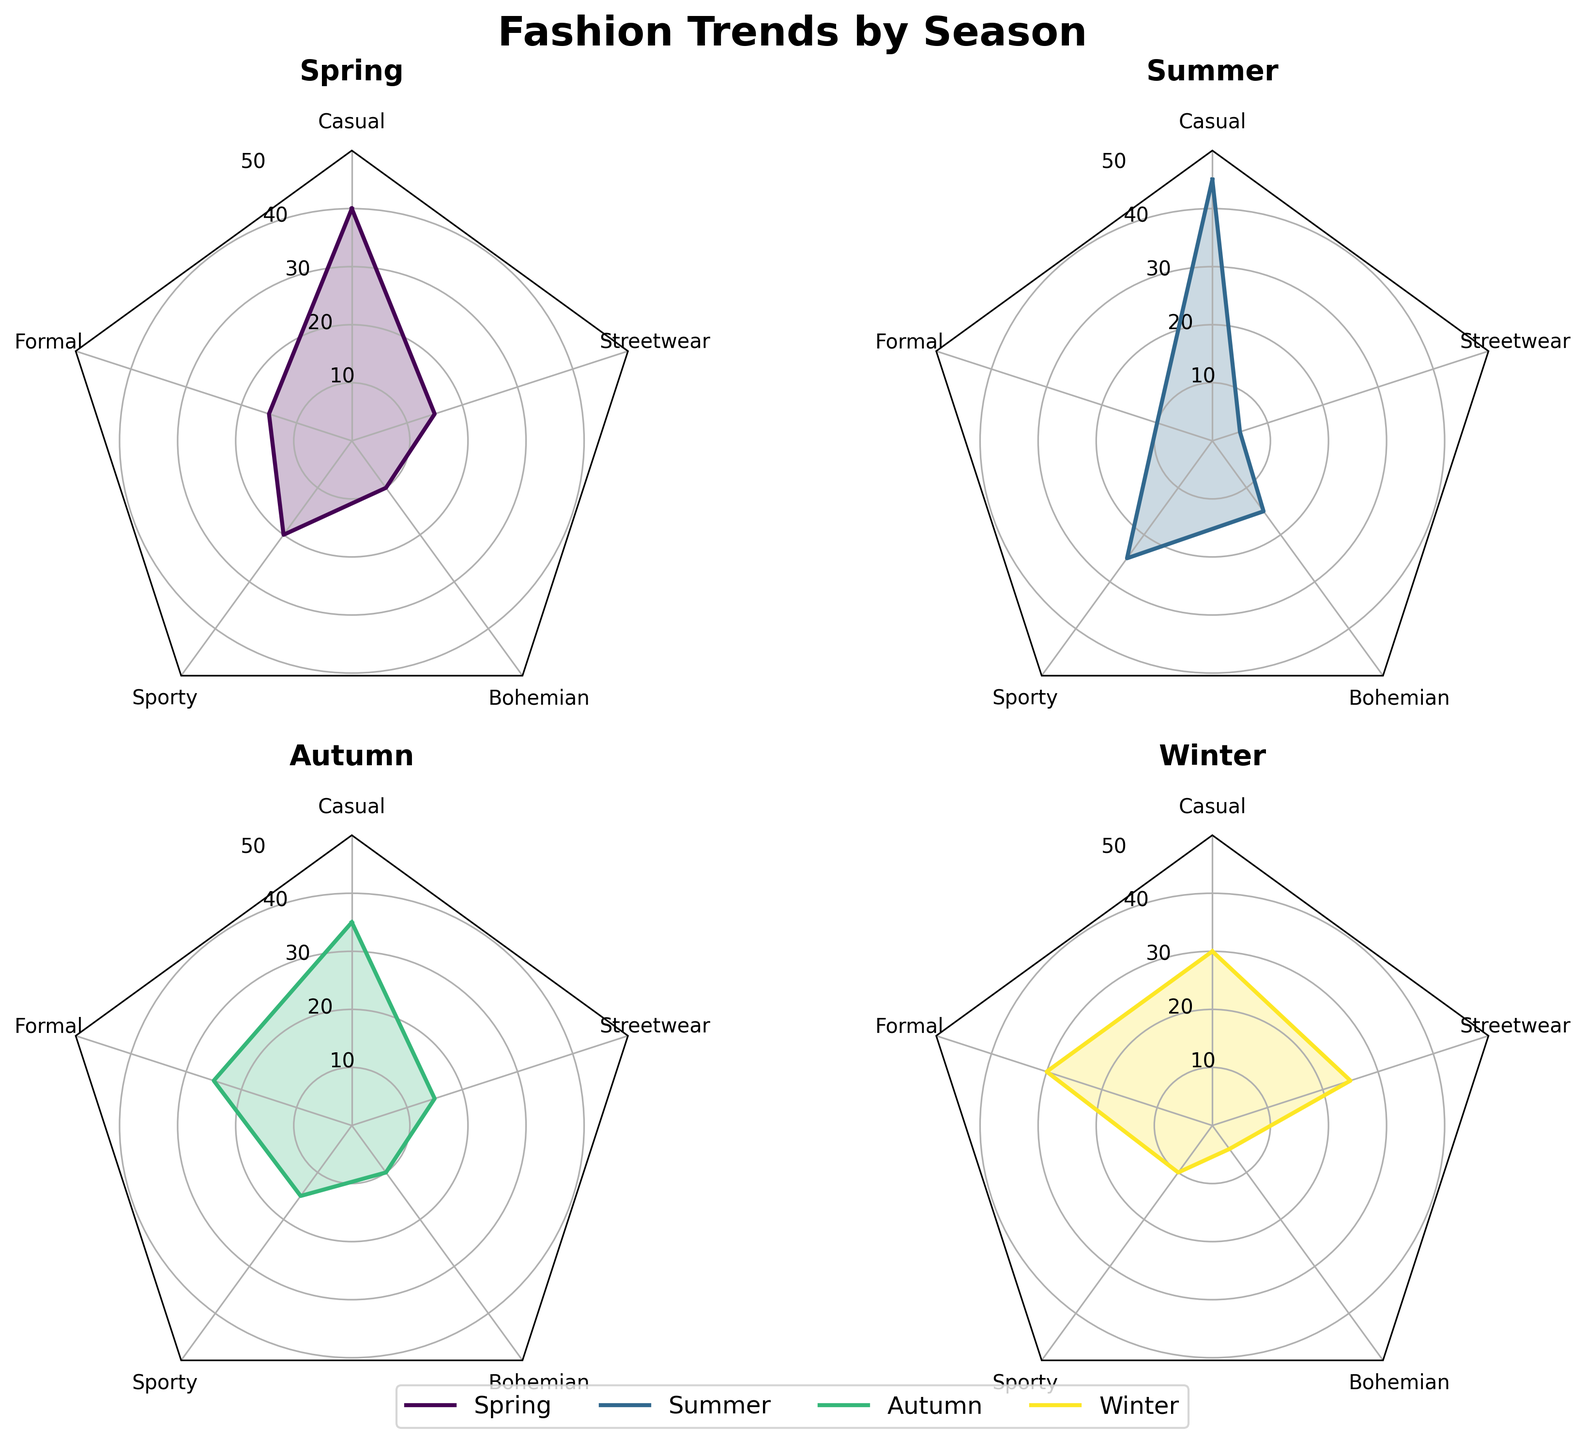What is the title of the radar chart? The title of the radar chart is typically displayed at the top of the figure and summarizes the main focus of the data being presented.
Answer: Fashion Trends by Season Which season has the highest percentage use of casual style? By looking at the radar charts, identify which season's dataset has the highest percentage at the position corresponding to the casual style.
Answer: Summer Which style is most prominent during autumn? Identify which style has the highest value in the radar chart for autumn.
Answer: Formal What is the percentage difference between the casual style in spring and winter? Subtract the percentage of casual style in winter from that in spring (40% - 30%).
Answer: 10% Compare the sporty style usage between summer and winter. Which season has a higher percentage? Check the radar charts for both summer and winter and compare the values at the sporty style position.
Answer: Summer How does the use of streetwear differ between spring and winter? Identify the percentages of streetwear for both spring and winter from their respective radar charts and calculate the difference (25% - 15%).
Answer: 10% What is the least favored style in summer? Look for the style with the smallest percentage in the summer radar chart.
Answer: Streetwear What is the average percentage use of the bohemian style across all seasons? Add up the percentages of bohemian style for all four seasons and divide by the number of seasons: (10% + 15% + 10% + 5%) / 4.
Answer: 10% Which season has the most balanced use of different styles? Analyze each radar chart to see which season has the closest percentages across all styles, indicating balanced distribution.
Answer: Spring 